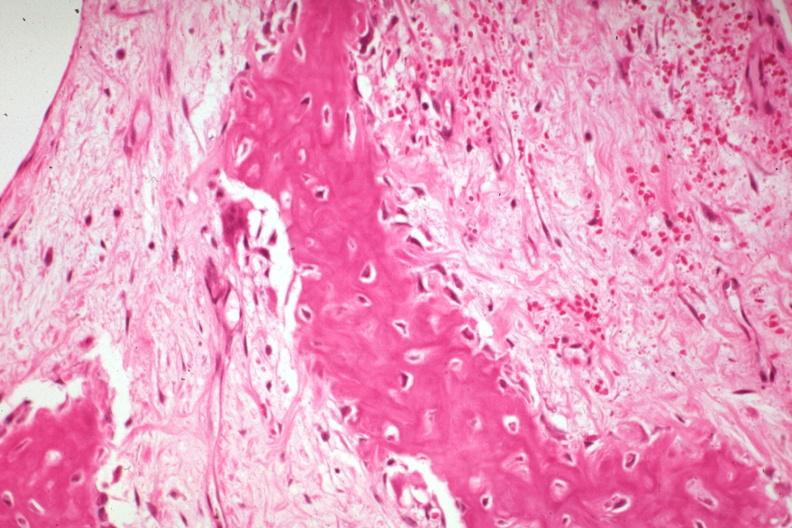how does this image show high fibrous callus?
Answer the question using a single word or phrase. With osteoid and osteoblasts 